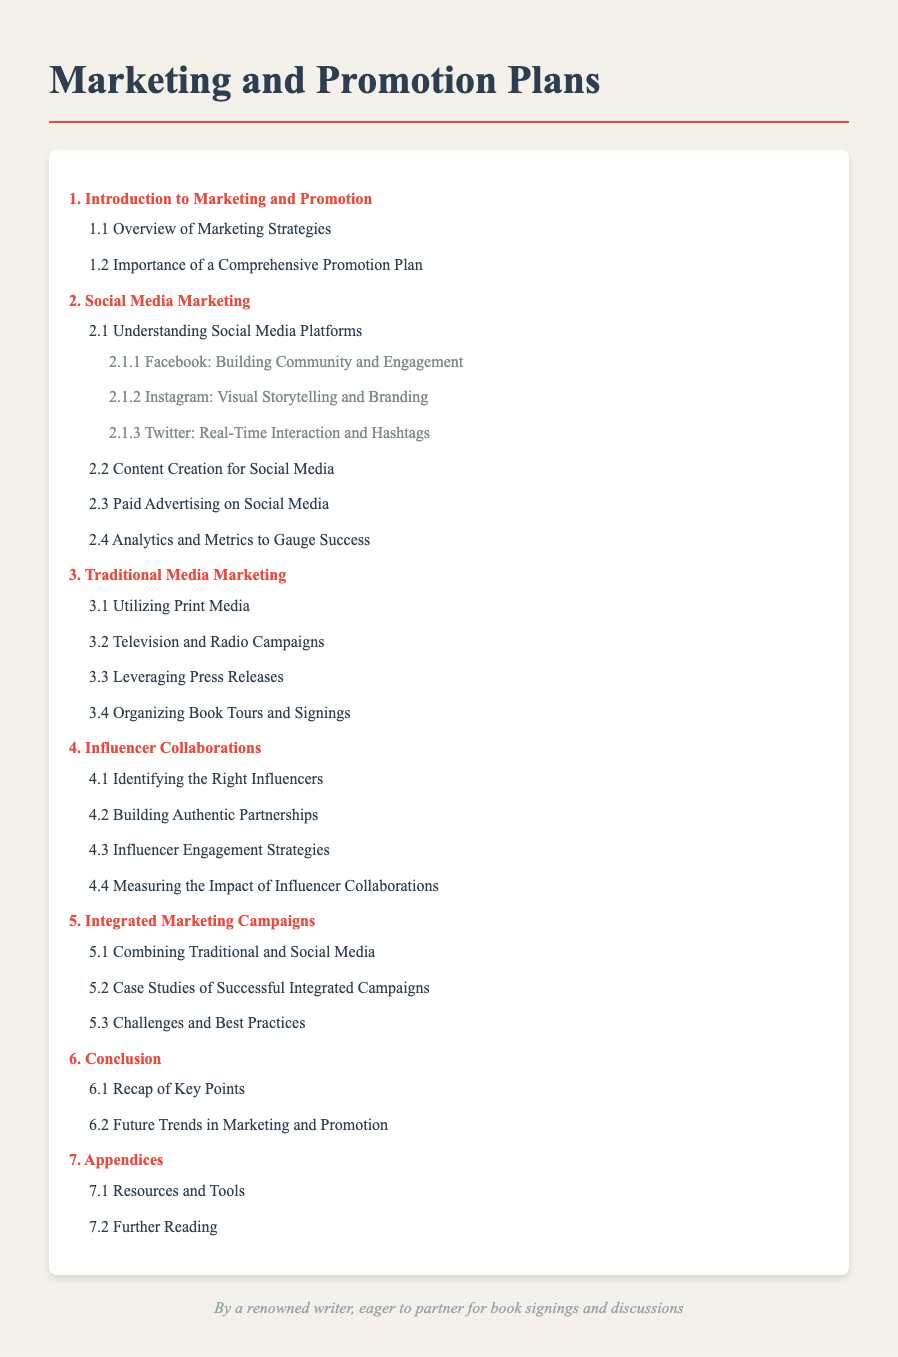What chapter discusses Social Media Marketing? The chapter focused on Social Media Marketing is clearly labeled as Chapter 2 in the table of contents.
Answer: 2. Social Media Marketing What subsection covers Instagram? Instagram is addressed in the subsection dedicated to understanding social media platforms, under Facebook, Instagram and Twitter.
Answer: 2.1.2 Instagram: Visual Storytelling and Branding How many sections are under Influencer Collaborations? The Influencer Collaborations chapter contains four distinct sections as listed in the table of contents.
Answer: 4 sections What is the main focus of Chapter 3? Chapter 3 is primarily concerned with Traditional Media Marketing, as stated in the title of the chapter.
Answer: Traditional Media Marketing Which chapter includes case studies? The chapter that includes case studies of successful integrated campaigns is Chapter 5.
Answer: 5. Integrated Marketing Campaigns What is the last section in the document? The final section of the document focuses on further reading, listed at the end of the appendices.
Answer: 7.2 Further Reading How many chapters are there in total? By counting the chapters listed, there are seven chapters outlined in the table of contents.
Answer: 7 chapters What does the author aim for in their note? The author's note expresses a desire to engage in partnerships for book signings and discussions.
Answer: Partnering for book signings and discussions 